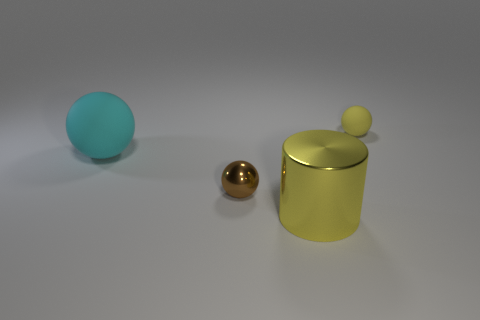What might be the function of the yellow container with the small ball on top? While we can't ascertain its exact function without more context, the yellow container resembles a decorative item, potentially a canister for holding small items or simply an ornamental piece due to its polished metallic finish and the small ball that acts as a handle on the lid. 